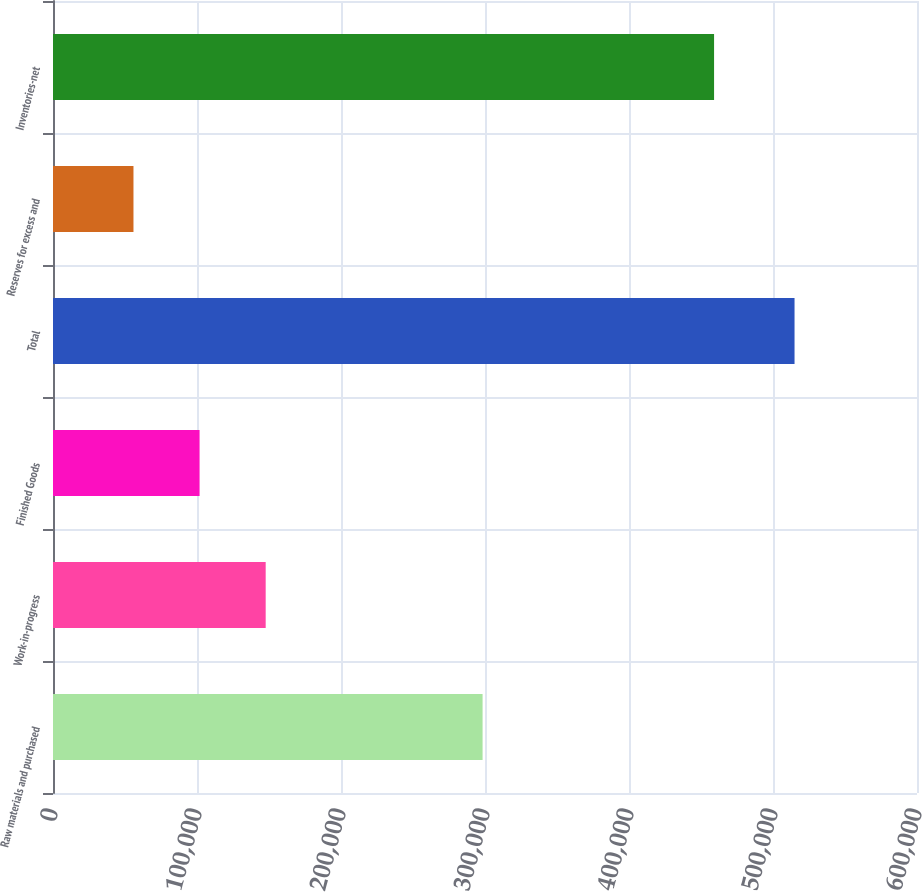<chart> <loc_0><loc_0><loc_500><loc_500><bar_chart><fcel>Raw materials and purchased<fcel>Work-in-progress<fcel>Finished Goods<fcel>Total<fcel>Reserves for excess and<fcel>Inventories-net<nl><fcel>298318<fcel>147697<fcel>101789<fcel>514956<fcel>55882<fcel>459074<nl></chart> 